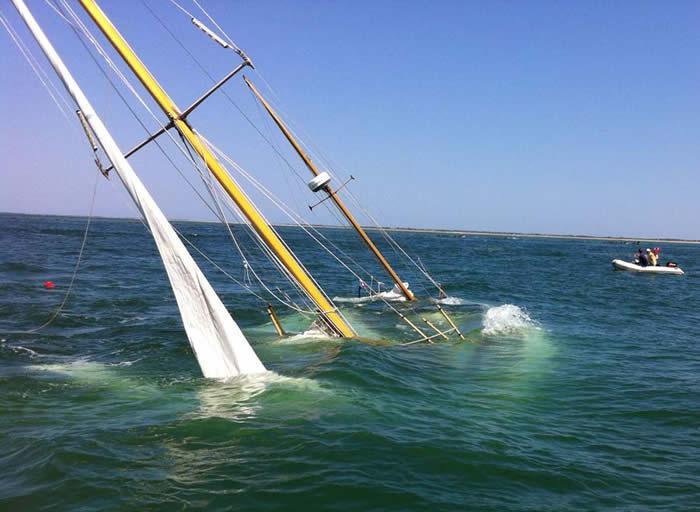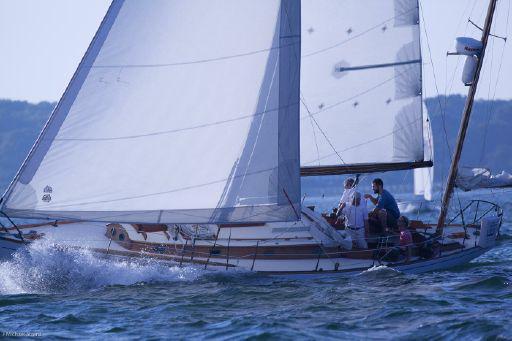The first image is the image on the left, the second image is the image on the right. Analyze the images presented: Is the assertion "The left and right image contains the same number of sailboats with three open sails." valid? Answer yes or no. No. The first image is the image on the left, the second image is the image on the right. Considering the images on both sides, is "The ship in the right image is sailing in front of a land bar" valid? Answer yes or no. No. 